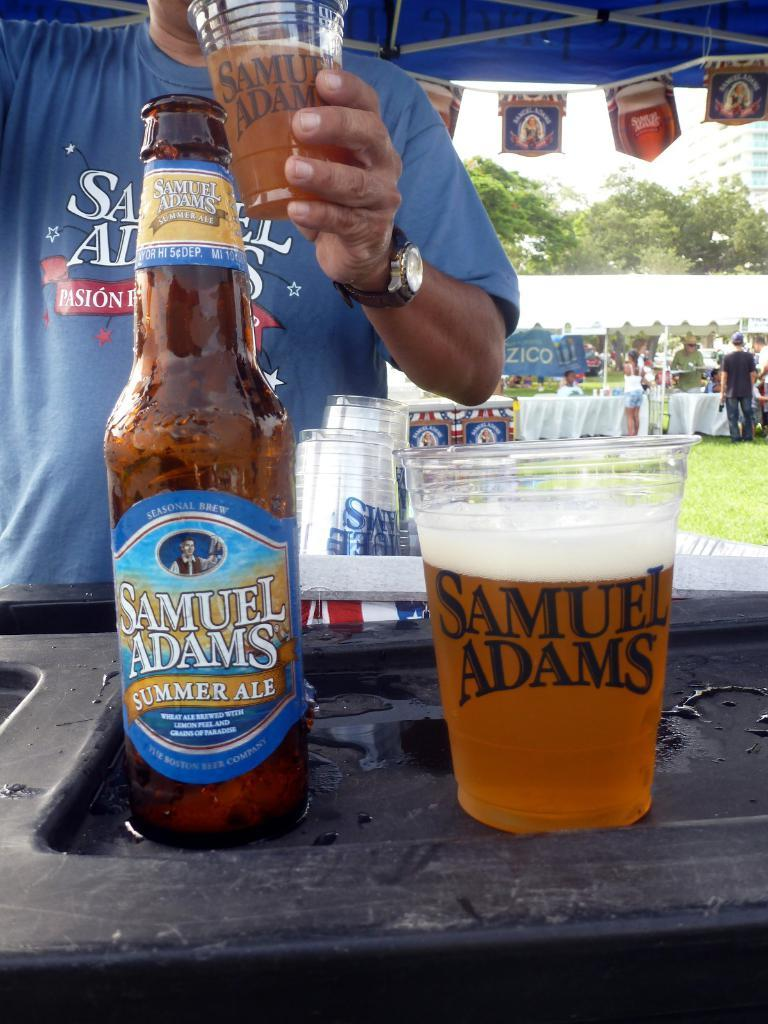Provide a one-sentence caption for the provided image. A Samuel Adams summer ale has been poured into a plastic cup at an outdoor festival. 